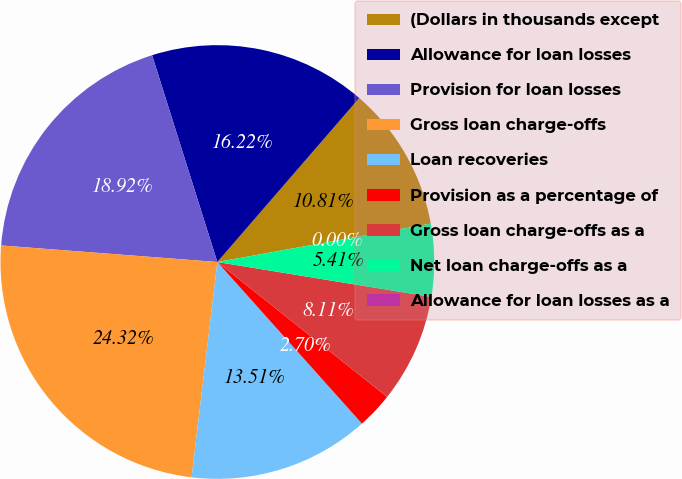Convert chart to OTSL. <chart><loc_0><loc_0><loc_500><loc_500><pie_chart><fcel>(Dollars in thousands except<fcel>Allowance for loan losses<fcel>Provision for loan losses<fcel>Gross loan charge-offs<fcel>Loan recoveries<fcel>Provision as a percentage of<fcel>Gross loan charge-offs as a<fcel>Net loan charge-offs as a<fcel>Allowance for loan losses as a<nl><fcel>10.81%<fcel>16.22%<fcel>18.92%<fcel>24.32%<fcel>13.51%<fcel>2.7%<fcel>8.11%<fcel>5.41%<fcel>0.0%<nl></chart> 